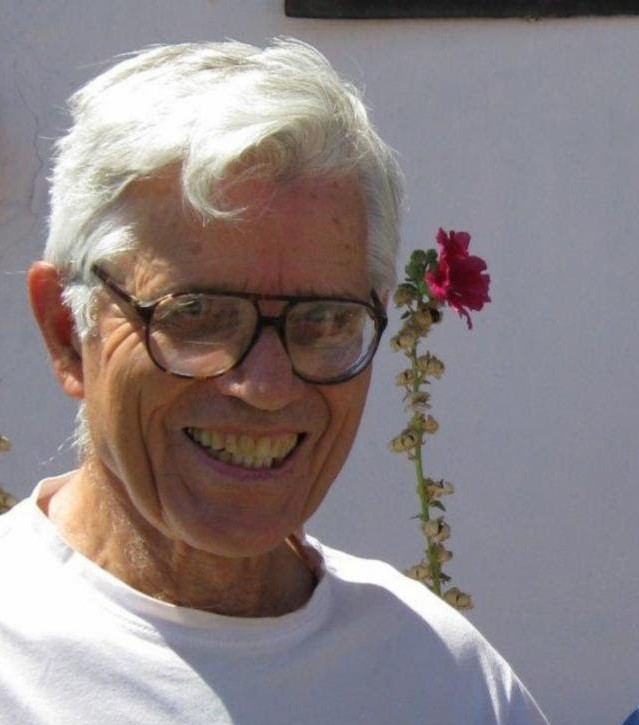Can you describe the overall mood of the man in this picture? The man in the picture radiates a joyful and cheerful mood. His broad smile and the twinkle in his eyes suggest that he is in high spirits, possibly sharing a light-hearted moment. The playful placement of the flower atop his head adds to the sense of fun and whimsy in the scene. What could be the reason behind his happiness? The man's happiness might stem from several possible reasons. He could be enjoying the company of friends or family, basking in pleasant weather, or simply finding joy in a playful moment with the flower. The serene background and his relaxed demeanor hint at a peaceful and enjoyable environment. 